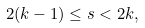Convert formula to latex. <formula><loc_0><loc_0><loc_500><loc_500>2 ( k - 1 ) \leq s < 2 k ,</formula> 